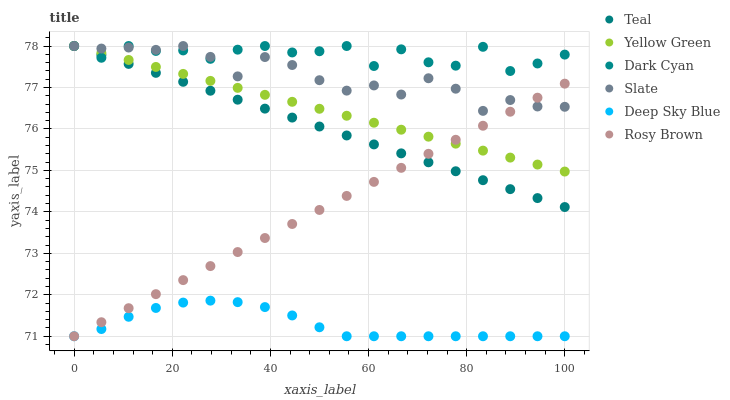Does Deep Sky Blue have the minimum area under the curve?
Answer yes or no. Yes. Does Dark Cyan have the maximum area under the curve?
Answer yes or no. Yes. Does Yellow Green have the minimum area under the curve?
Answer yes or no. No. Does Yellow Green have the maximum area under the curve?
Answer yes or no. No. Is Yellow Green the smoothest?
Answer yes or no. Yes. Is Dark Cyan the roughest?
Answer yes or no. Yes. Is Slate the smoothest?
Answer yes or no. No. Is Slate the roughest?
Answer yes or no. No. Does Rosy Brown have the lowest value?
Answer yes or no. Yes. Does Yellow Green have the lowest value?
Answer yes or no. No. Does Dark Cyan have the highest value?
Answer yes or no. Yes. Does Rosy Brown have the highest value?
Answer yes or no. No. Is Deep Sky Blue less than Slate?
Answer yes or no. Yes. Is Dark Cyan greater than Rosy Brown?
Answer yes or no. Yes. Does Rosy Brown intersect Deep Sky Blue?
Answer yes or no. Yes. Is Rosy Brown less than Deep Sky Blue?
Answer yes or no. No. Is Rosy Brown greater than Deep Sky Blue?
Answer yes or no. No. Does Deep Sky Blue intersect Slate?
Answer yes or no. No. 